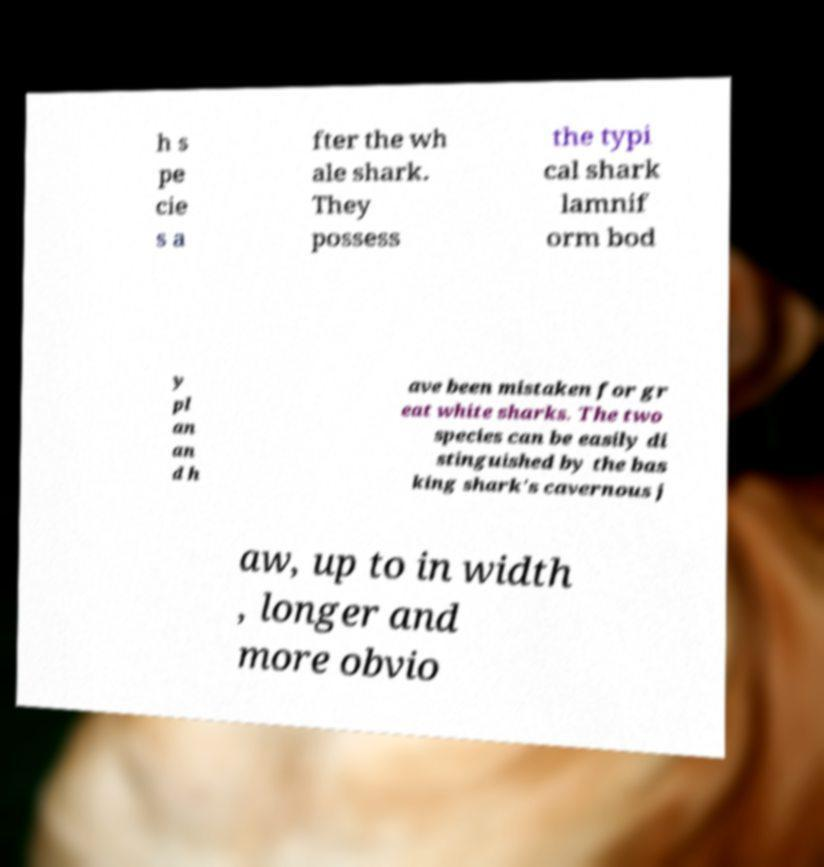I need the written content from this picture converted into text. Can you do that? h s pe cie s a fter the wh ale shark. They possess the typi cal shark lamnif orm bod y pl an an d h ave been mistaken for gr eat white sharks. The two species can be easily di stinguished by the bas king shark's cavernous j aw, up to in width , longer and more obvio 